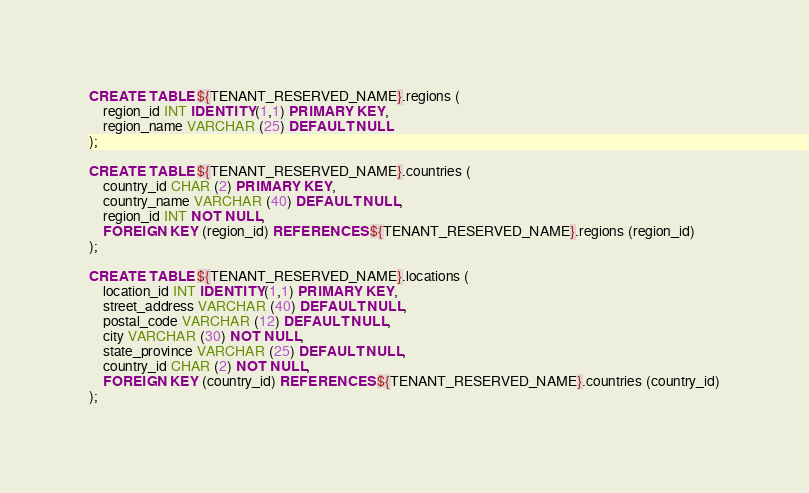Convert code to text. <code><loc_0><loc_0><loc_500><loc_500><_SQL_>CREATE TABLE ${TENANT_RESERVED_NAME}.regions (
    region_id INT IDENTITY(1,1) PRIMARY KEY,
    region_name VARCHAR (25) DEFAULT NULL
);
 
CREATE TABLE ${TENANT_RESERVED_NAME}.countries (
    country_id CHAR (2) PRIMARY KEY,
    country_name VARCHAR (40) DEFAULT NULL,
    region_id INT NOT NULL,
    FOREIGN KEY (region_id) REFERENCES ${TENANT_RESERVED_NAME}.regions (region_id)
);
 
CREATE TABLE ${TENANT_RESERVED_NAME}.locations (
    location_id INT IDENTITY(1,1) PRIMARY KEY,
    street_address VARCHAR (40) DEFAULT NULL,
    postal_code VARCHAR (12) DEFAULT NULL,
    city VARCHAR (30) NOT NULL,
    state_province VARCHAR (25) DEFAULT NULL,
    country_id CHAR (2) NOT NULL,
    FOREIGN KEY (country_id) REFERENCES ${TENANT_RESERVED_NAME}.countries (country_id)
);
</code> 